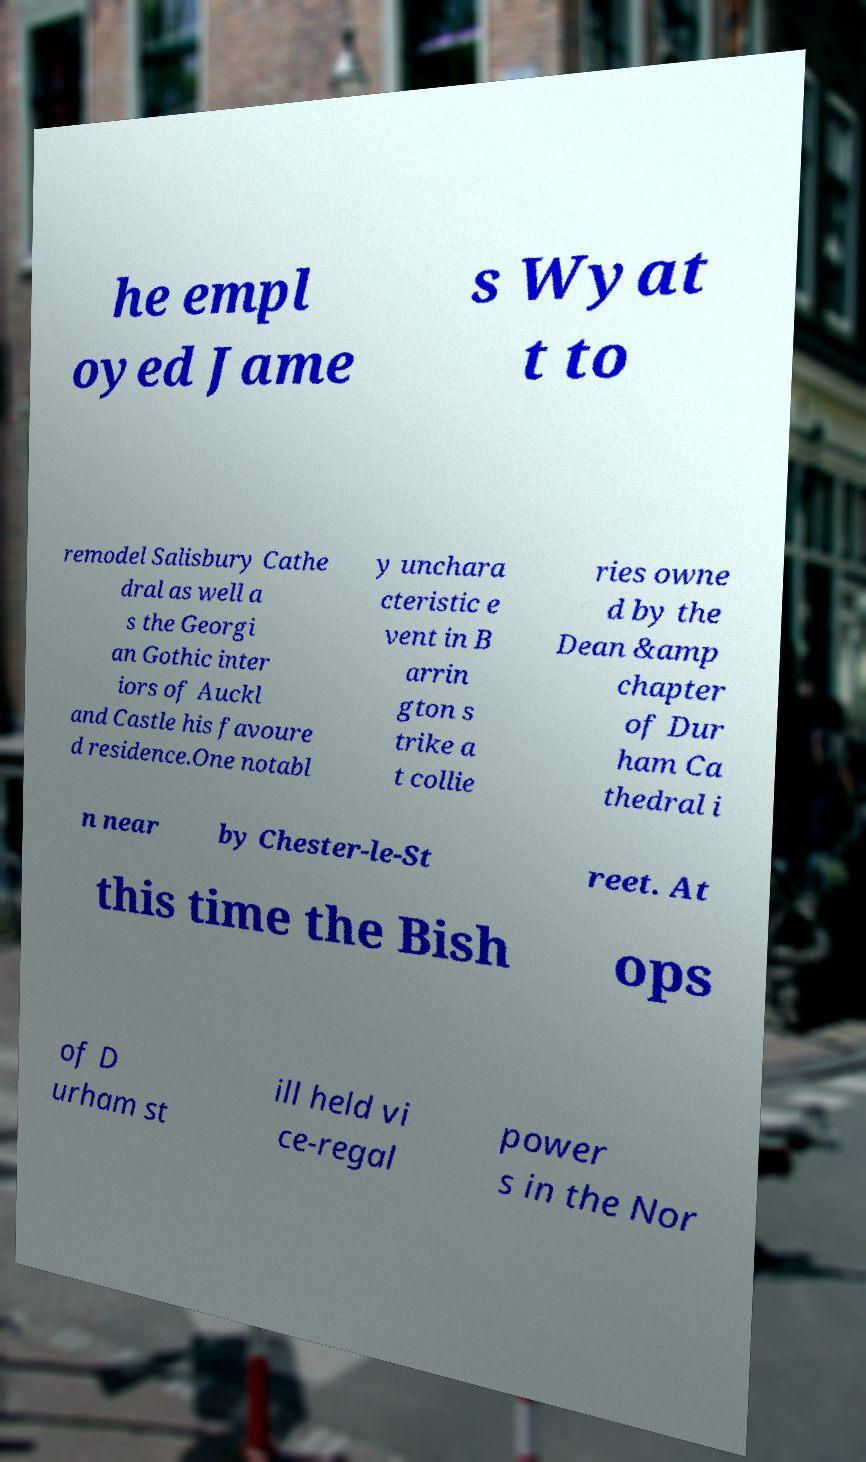Please identify and transcribe the text found in this image. he empl oyed Jame s Wyat t to remodel Salisbury Cathe dral as well a s the Georgi an Gothic inter iors of Auckl and Castle his favoure d residence.One notabl y unchara cteristic e vent in B arrin gton s trike a t collie ries owne d by the Dean &amp chapter of Dur ham Ca thedral i n near by Chester-le-St reet. At this time the Bish ops of D urham st ill held vi ce-regal power s in the Nor 